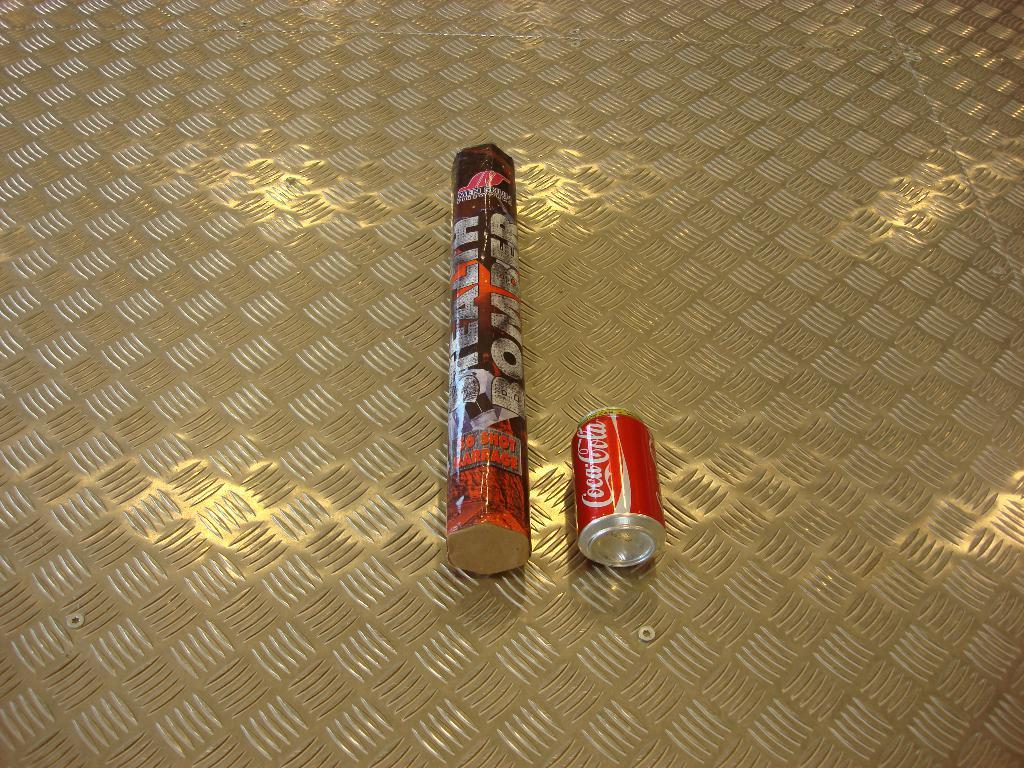Provide a one-sentence caption for the provided image. A coca-cola can lays next to a stealth bomber package. 